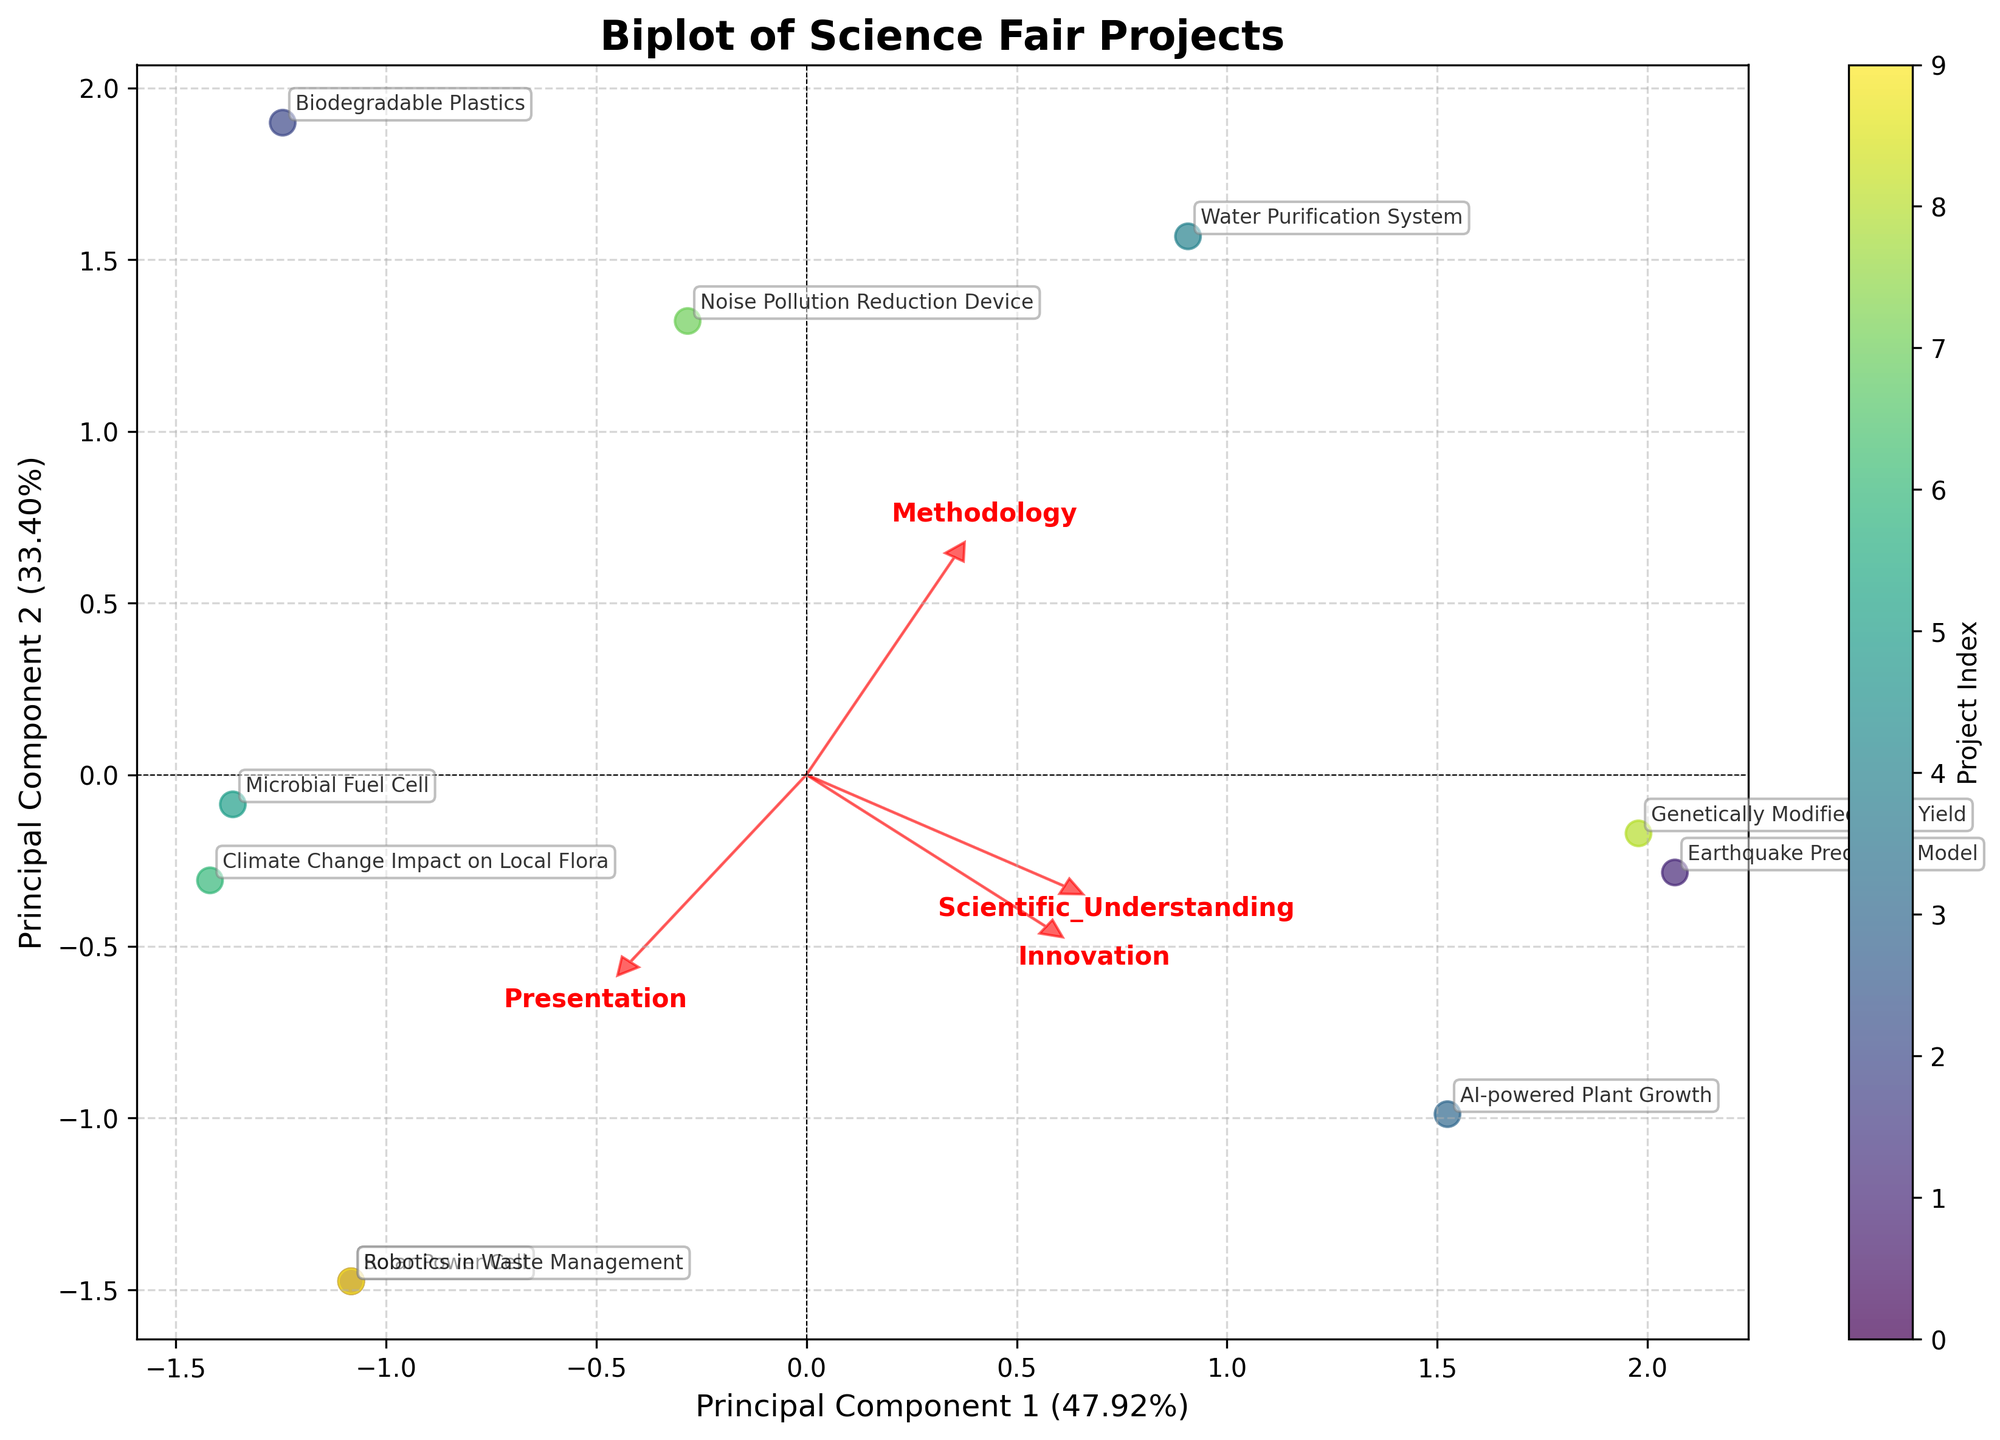What is the title of the plot? The title of the plot is located at the top and it reads, "Biplot of Science Fair Projects".
Answer: Biplot of Science Fair Projects How many projects are represented in the biplot? Count the number of distinct data points or labeled projects in the biplot. There are 10 projects labeled on the graph.
Answer: 10 Which principal component explains more variance in the data, PC1 or PC2? Refer to the axis labels. The x-axis (PC1) explains 55.16% of the variance, while the y-axis (PC2) explains 22.12%. PC1 explains more variance.
Answer: PC1 Which project is closest to the center of the plot? Locate the project label that is nearest to the origin (0,0). The "Microbial Fuel Cell" project is closest to the center.
Answer: Microbial Fuel Cell Which feature vector points closest to the right? Look at the direction of the red arrows representing feature vectors. The "Methodology" feature vector points closest to the right.
Answer: Methodology Among the four features, which has the least influence on the second principal component (PC2)? Check the red arrows and note their vertical coordinates. The feature with the smallest vertical projection is "Innovation".
Answer: Innovation Which project has the highest score along PC1? Identify the project with the highest x-coordinate value. The "Genetically Modified Crop Yield" project is situated at the far right along the x-axis, indicating the highest score on PC1.
Answer: Genetically Modified Crop Yield Is the "Robotics in Waste Management" project more influenced by "Presentation" or "Scientific Understanding"? Check the directions of the red feature vectors and compare the position of the "Robotics in Waste Management" project relative to these vectors. The project is more aligned with "Presentation".
Answer: Presentation Between "AI-powered Plant Growth" and "Water Purification System", which project has a higher PC2 score? Compare the y-coordinates of the two projects. The "AI-powered Plant Growth" project is higher along the y-axis (PC2) than the "Water Purification System" project.
Answer: AI-powered Plant Growth What trend can be inferred from how the projects are distributed in relation to "Innovation" and "Presentation"? Identify the general direction of the feature vectors for "Innovation" and "Presentation" and observe how the projects align along these vectors. Projects with high innovation scores also tend to have high presentation scores, as both vectors point similarly upwards.
Answer: Projects with high innovation also tend to have high presentation scores 